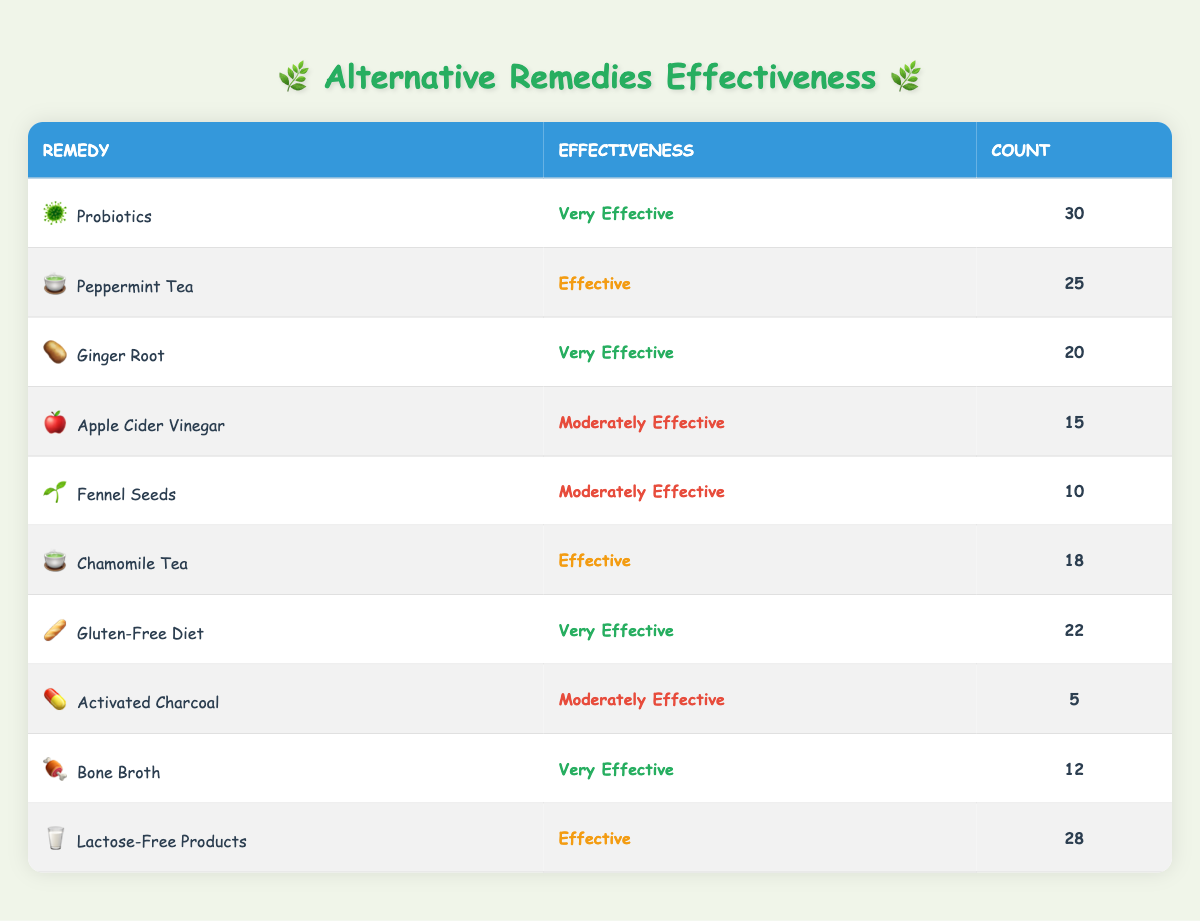What is the count of people who found Probiotics very effective? The table lists Probiotics with an effectiveness rating of "Very Effective" and a count of 30, so the answer is directly taken from this row.
Answer: 30 Which remedies are rated as Moderately Effective? By scanning the effectiveness column, the remedies listed as "Moderately Effective" are Apple Cider Vinegar, Fennel Seeds, and Activated Charcoal.
Answer: Apple Cider Vinegar, Fennel Seeds, Activated Charcoal What is the total count of people who found remedies Very Effective? The count for remedies rated "Very Effective" are Probiotics (30), Ginger Root (20), Gluten-Free Diet (22), and Bone Broth (12). The total is calculated as 30 + 20 + 22 + 12 = 84.
Answer: 84 Is Lactose-Free Products rated as Effective? In the table, Lactose-Free Products have an effectiveness rating of "Effective", so the answer is true.
Answer: Yes Which remedy with the least count has the highest effectiveness rating? The remedy with the least count is Activated Charcoal (5), which is rated as "Moderately Effective". The highest effectiveness rating among all remedies is "Very Effective". Hence, comparing the counts, Activated Charcoal is the least but still does not reach "Very Effective". Looking at all remedies, the least count with the highest rating holds is still considerably the same.
Answer: Activated Charcoal What is the ratio of those who found Peppermint Tea effective to those who found Ginger Root very effective? The count for Peppermint Tea (25) is compared to Ginger Root (20). The ratio is calculated as 25:20, which simplifies to 5:4.
Answer: 5:4 Which remedy has the highest count and what is its effectiveness rating? Upon reviewing the table, Probiotics have the highest count of 30, and they are rated as "Very Effective". Therefore, it reflects a direct association of highest count with effectiveness rating: Very Effective.
Answer: Probiotics, Very Effective How many more people rated Lactose-Free Products as Effective compared to Fennel Seeds rated as Moderately Effective? The count for Lactose-Free Products is 28 and for Fennel Seeds, it is 10. Therefore, 28 - 10 = 18 more people rated Lactose-Free Products as Effective.
Answer: 18 